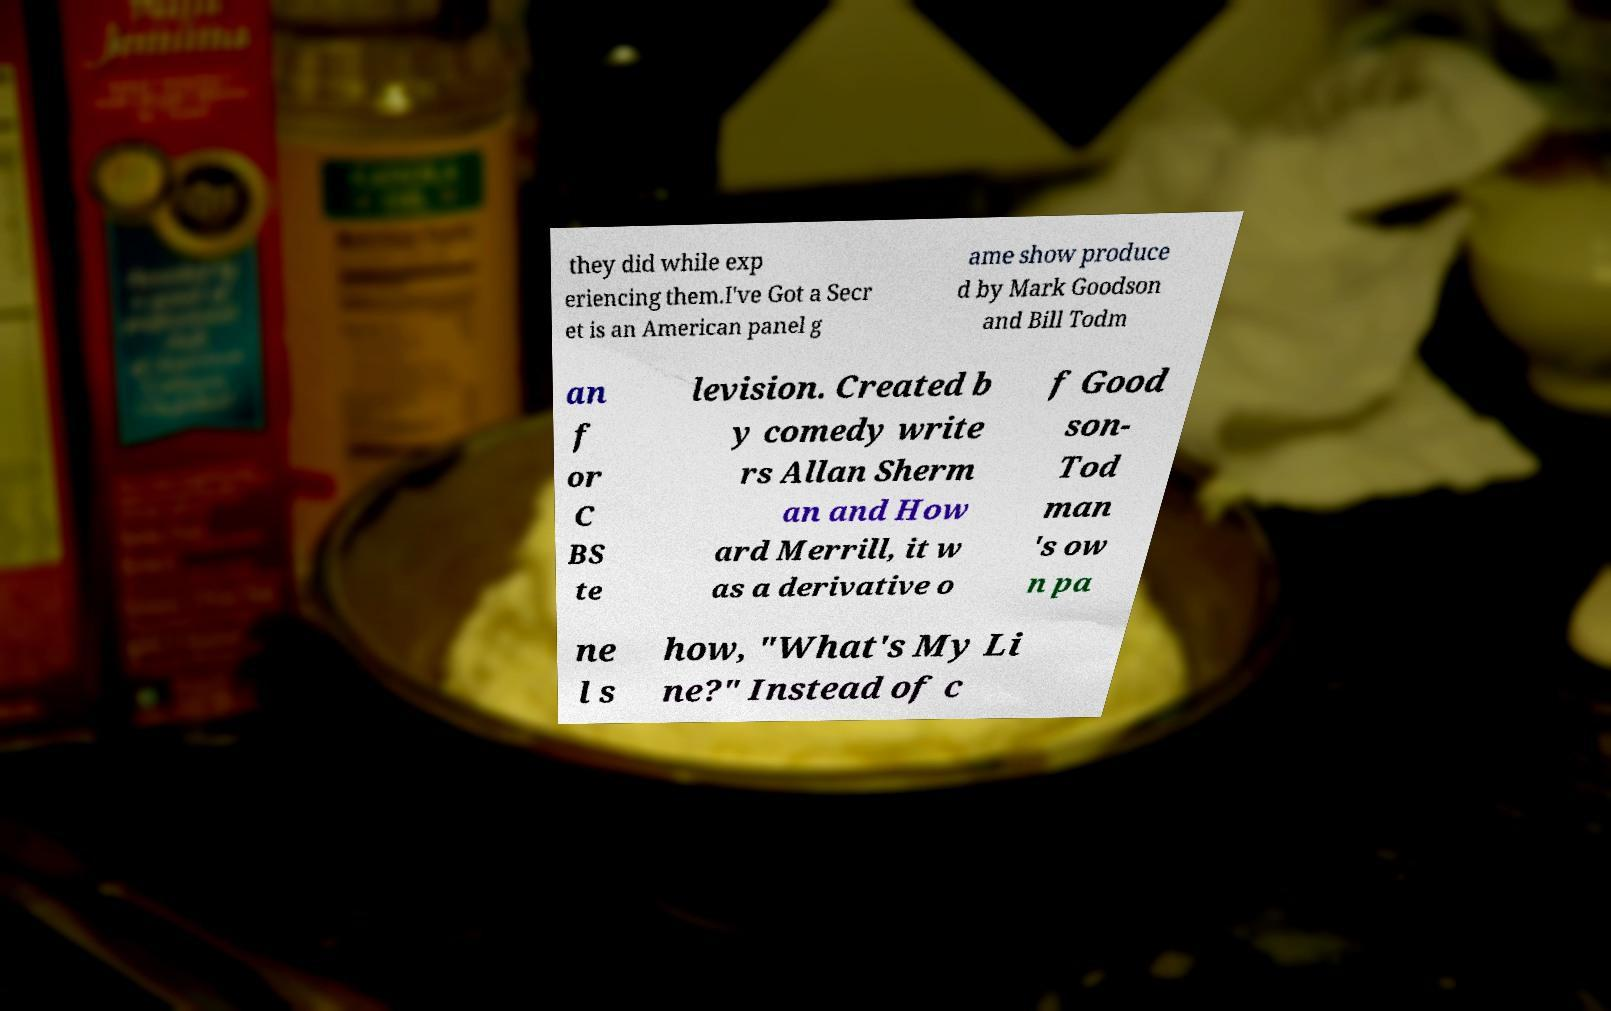Could you extract and type out the text from this image? they did while exp eriencing them.I've Got a Secr et is an American panel g ame show produce d by Mark Goodson and Bill Todm an f or C BS te levision. Created b y comedy write rs Allan Sherm an and How ard Merrill, it w as a derivative o f Good son- Tod man 's ow n pa ne l s how, "What's My Li ne?" Instead of c 